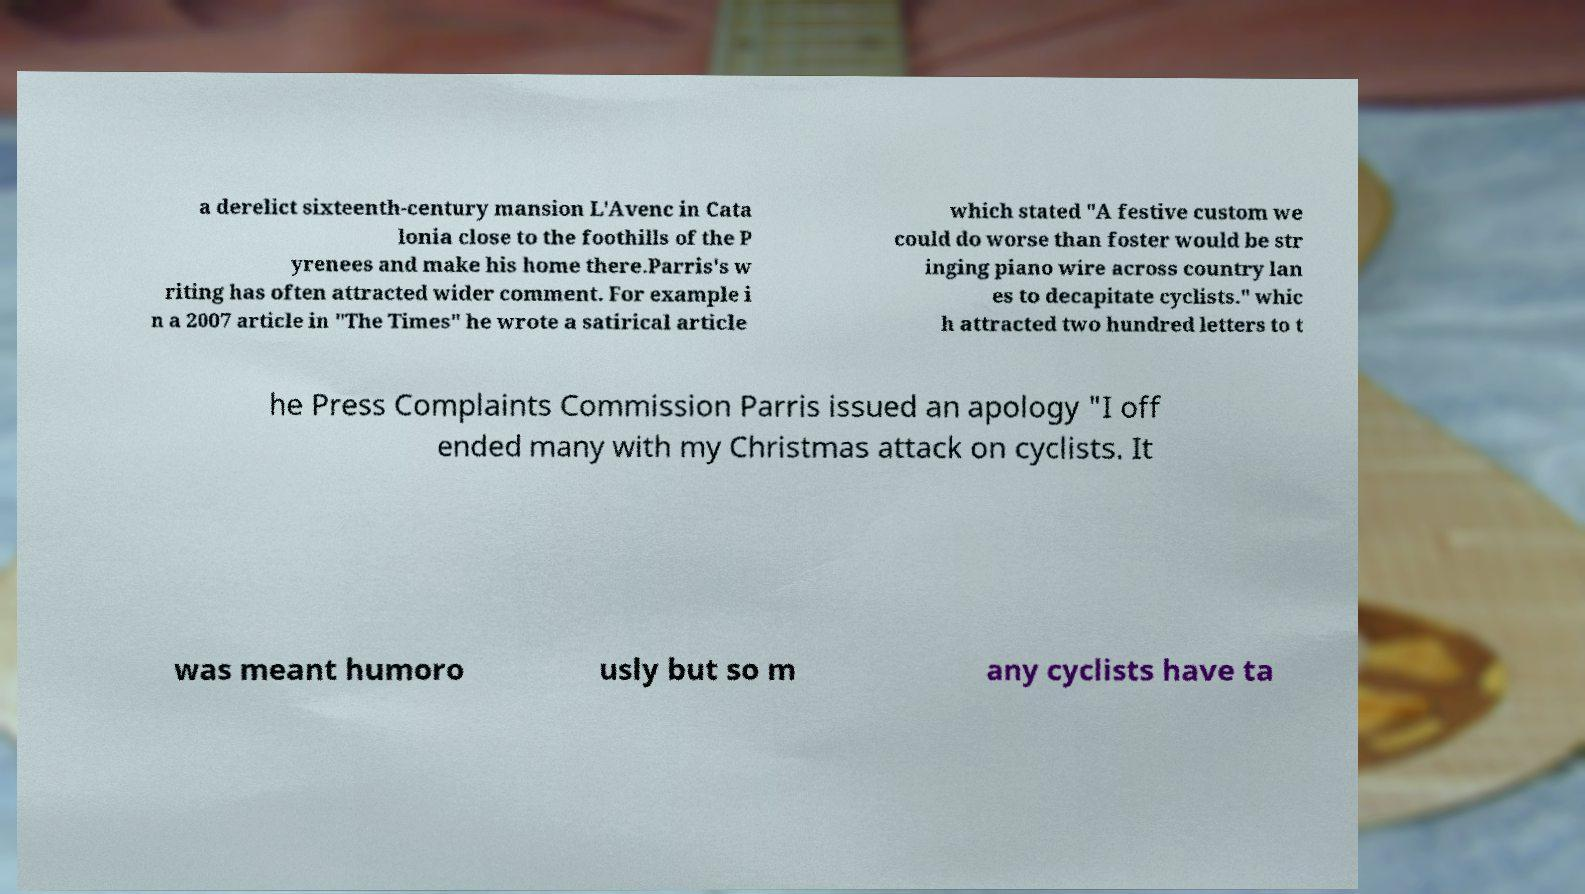What messages or text are displayed in this image? I need them in a readable, typed format. a derelict sixteenth-century mansion L'Avenc in Cata lonia close to the foothills of the P yrenees and make his home there.Parris's w riting has often attracted wider comment. For example i n a 2007 article in "The Times" he wrote a satirical article which stated "A festive custom we could do worse than foster would be str inging piano wire across country lan es to decapitate cyclists." whic h attracted two hundred letters to t he Press Complaints Commission Parris issued an apology "I off ended many with my Christmas attack on cyclists. It was meant humoro usly but so m any cyclists have ta 